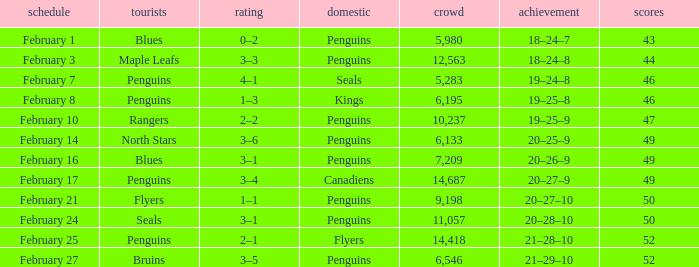Record of 21–29–10 had what total number of points? 1.0. 